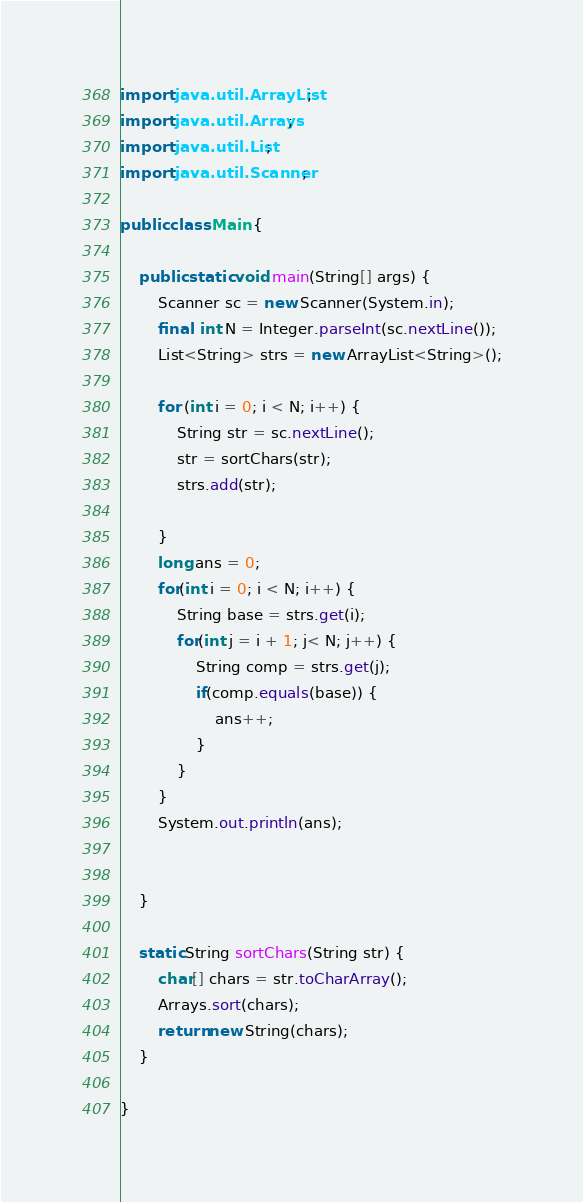Convert code to text. <code><loc_0><loc_0><loc_500><loc_500><_Java_>import java.util.ArrayList;
import java.util.Arrays;
import java.util.List;
import java.util.Scanner;

public class Main {

	public static void main(String[] args) {
		Scanner sc = new Scanner(System.in);
		final  int N = Integer.parseInt(sc.nextLine());
		List<String> strs = new ArrayList<String>();

		for (int i = 0; i < N; i++) {
			String str = sc.nextLine();
			str = sortChars(str);
			strs.add(str);

		}
		long ans = 0;
		for(int i = 0; i < N; i++) {
			String base = strs.get(i);
			for(int j = i + 1; j< N; j++) {
				String comp = strs.get(j);
				if(comp.equals(base)) {
					ans++;
				}
			}
		}
		System.out.println(ans);


	}

	static String sortChars(String str) {
		char[] chars = str.toCharArray();
		Arrays.sort(chars);
		return new String(chars);
	}

}
</code> 